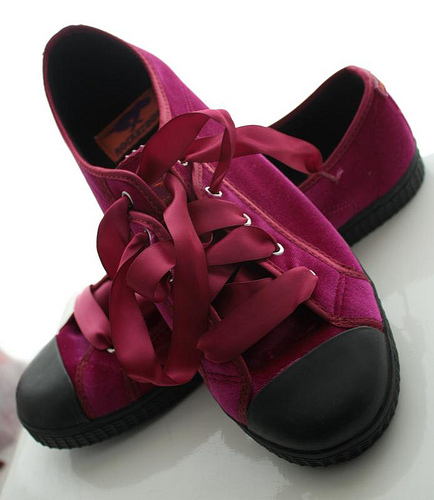<image>
Can you confirm if the shoe is under the shoe? Yes. The shoe is positioned underneath the shoe, with the shoe above it in the vertical space. 